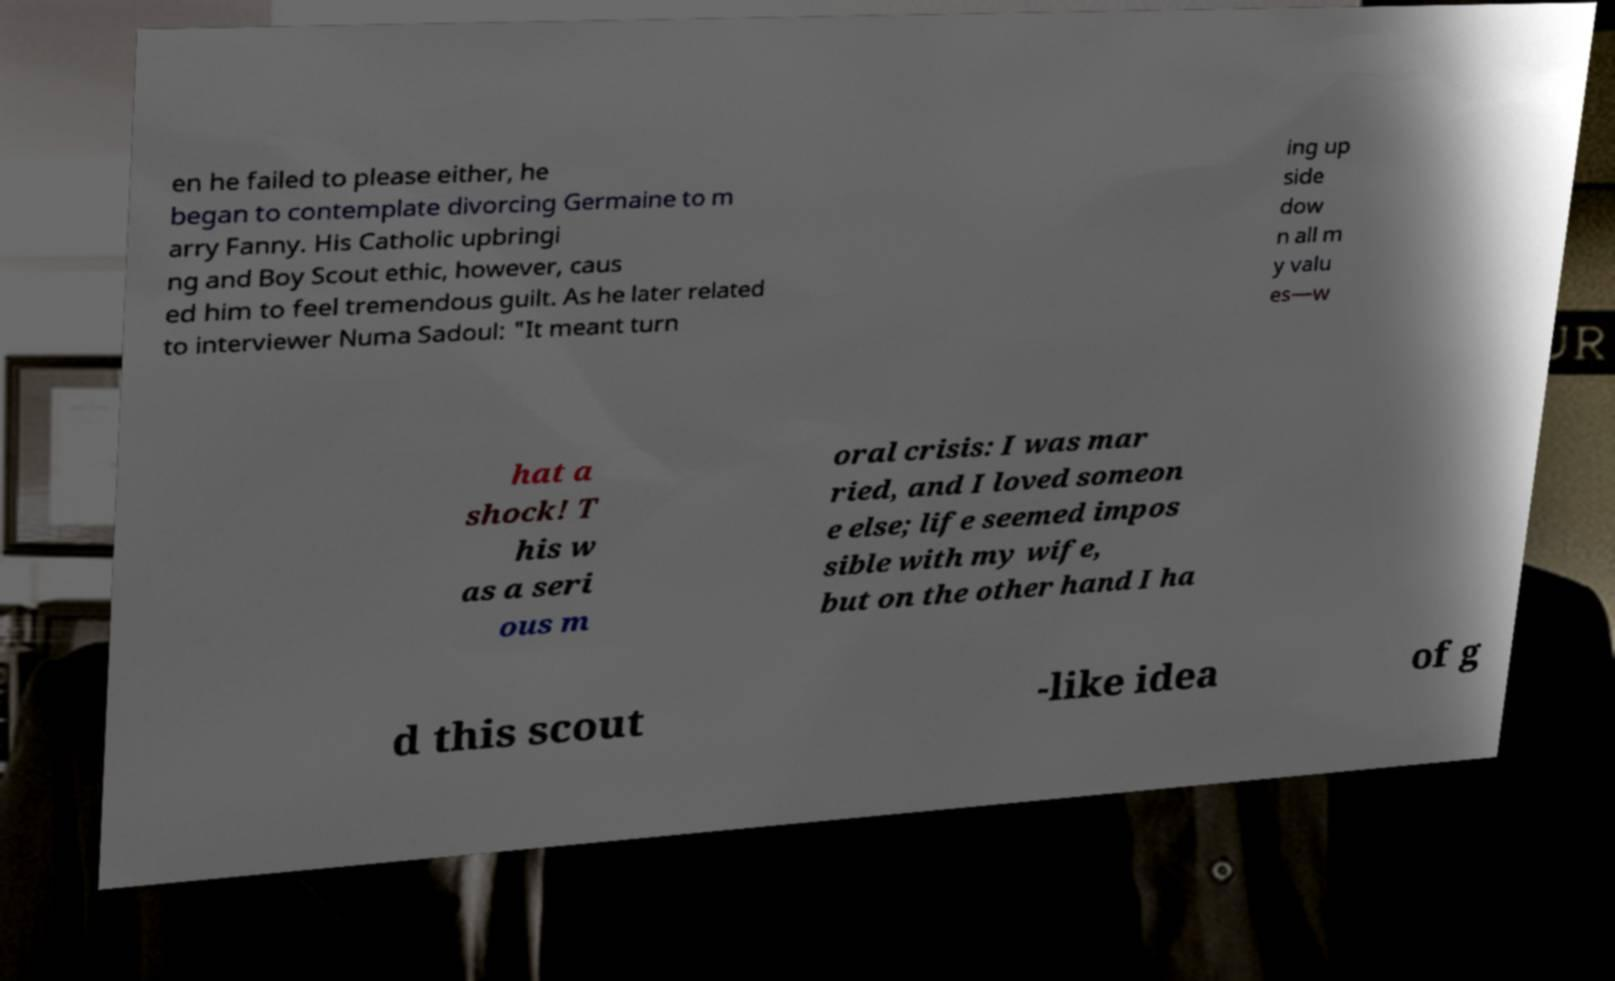Please read and relay the text visible in this image. What does it say? en he failed to please either, he began to contemplate divorcing Germaine to m arry Fanny. His Catholic upbringi ng and Boy Scout ethic, however, caus ed him to feel tremendous guilt. As he later related to interviewer Numa Sadoul: "It meant turn ing up side dow n all m y valu es—w hat a shock! T his w as a seri ous m oral crisis: I was mar ried, and I loved someon e else; life seemed impos sible with my wife, but on the other hand I ha d this scout -like idea of g 